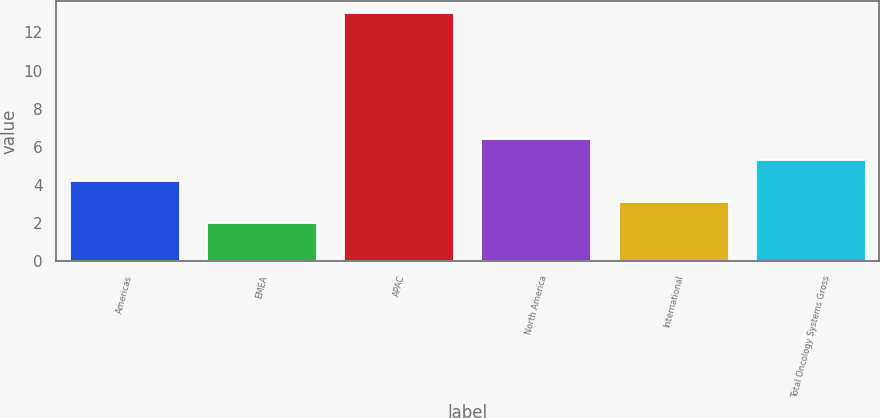<chart> <loc_0><loc_0><loc_500><loc_500><bar_chart><fcel>Americas<fcel>EMEA<fcel>APAC<fcel>North America<fcel>International<fcel>Total Oncology Systems Gross<nl><fcel>4.2<fcel>2<fcel>13<fcel>6.4<fcel>3.1<fcel>5.3<nl></chart> 